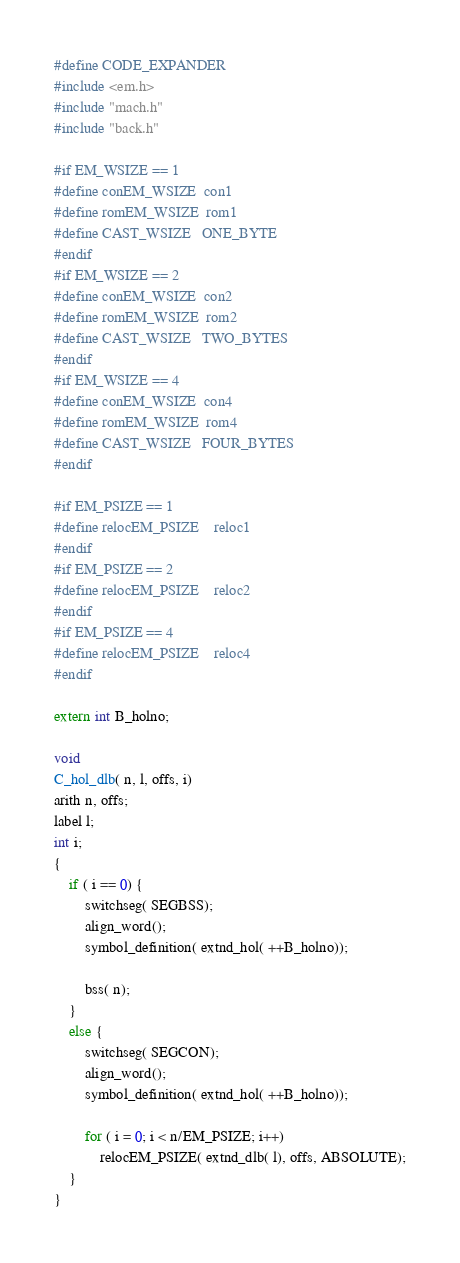<code> <loc_0><loc_0><loc_500><loc_500><_C_>#define CODE_EXPANDER
#include <em.h>
#include "mach.h"
#include "back.h"

#if EM_WSIZE == 1
#define conEM_WSIZE	con1
#define romEM_WSIZE	rom1
#define CAST_WSIZE	ONE_BYTE
#endif
#if EM_WSIZE == 2
#define conEM_WSIZE	con2
#define romEM_WSIZE	rom2
#define CAST_WSIZE	TWO_BYTES
#endif
#if EM_WSIZE == 4
#define conEM_WSIZE	con4
#define romEM_WSIZE	rom4
#define CAST_WSIZE	FOUR_BYTES
#endif

#if EM_PSIZE == 1
#define relocEM_PSIZE	reloc1
#endif
#if EM_PSIZE == 2
#define relocEM_PSIZE	reloc2
#endif
#if EM_PSIZE == 4
#define relocEM_PSIZE	reloc4
#endif

extern int B_holno;

void
C_hol_dlb( n, l, offs, i)
arith n, offs;
label l;
int i;
{
	if ( i == 0) {
		switchseg( SEGBSS);
		align_word();
		symbol_definition( extnd_hol( ++B_holno));

		bss( n);
	}
	else {  
		switchseg( SEGCON);
		align_word();
		symbol_definition( extnd_hol( ++B_holno));

		for ( i = 0; i < n/EM_PSIZE; i++)
			relocEM_PSIZE( extnd_dlb( l), offs, ABSOLUTE);
	}
}
</code> 